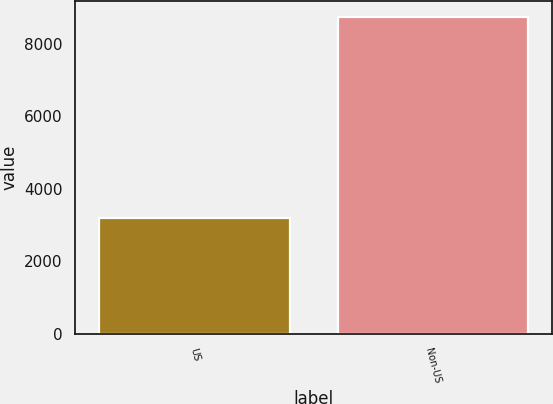Convert chart. <chart><loc_0><loc_0><loc_500><loc_500><bar_chart><fcel>US<fcel>Non-US<nl><fcel>3192<fcel>8741<nl></chart> 